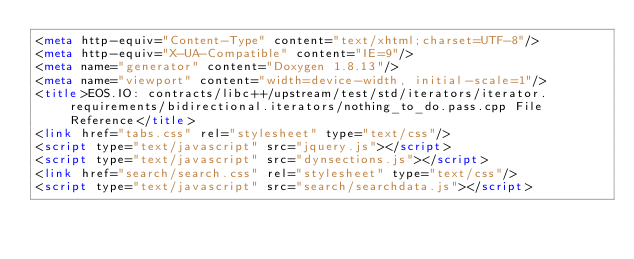<code> <loc_0><loc_0><loc_500><loc_500><_HTML_><meta http-equiv="Content-Type" content="text/xhtml;charset=UTF-8"/>
<meta http-equiv="X-UA-Compatible" content="IE=9"/>
<meta name="generator" content="Doxygen 1.8.13"/>
<meta name="viewport" content="width=device-width, initial-scale=1"/>
<title>EOS.IO: contracts/libc++/upstream/test/std/iterators/iterator.requirements/bidirectional.iterators/nothing_to_do.pass.cpp File Reference</title>
<link href="tabs.css" rel="stylesheet" type="text/css"/>
<script type="text/javascript" src="jquery.js"></script>
<script type="text/javascript" src="dynsections.js"></script>
<link href="search/search.css" rel="stylesheet" type="text/css"/>
<script type="text/javascript" src="search/searchdata.js"></script></code> 